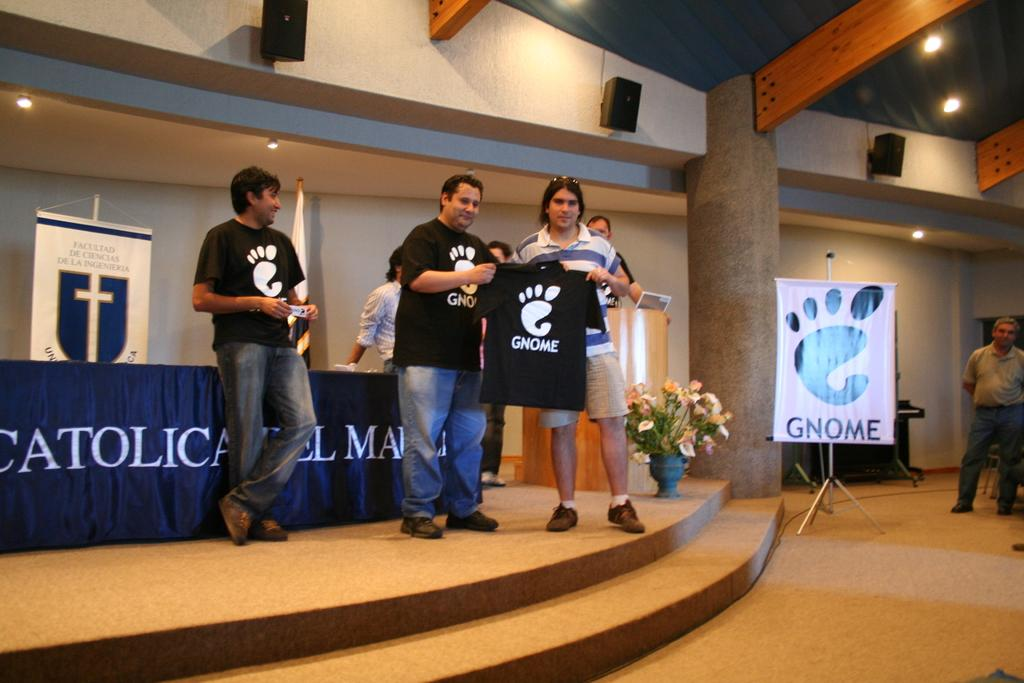<image>
Give a short and clear explanation of the subsequent image. A man holds a shirt up with the word gnome on it. 